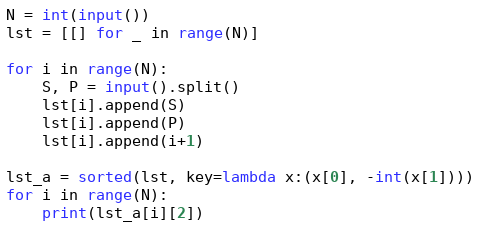<code> <loc_0><loc_0><loc_500><loc_500><_Python_>N = int(input())
lst = [[] for _ in range(N)]

for i in range(N):
    S, P = input().split()
    lst[i].append(S)
    lst[i].append(P)
    lst[i].append(i+1)
    
lst_a = sorted(lst, key=lambda x:(x[0], -int(x[1])))
for i in range(N):
    print(lst_a[i][2])</code> 